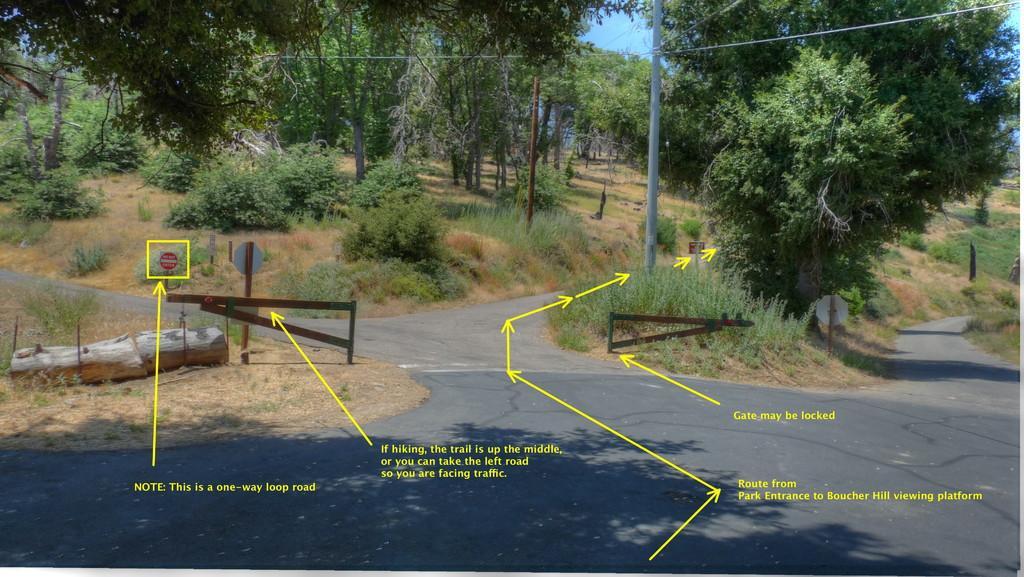Can you describe this image briefly? In this image there is a road on that road there is a gate, log, pole, sign boards, in the background there are trees and there are arrow marks and some text. 